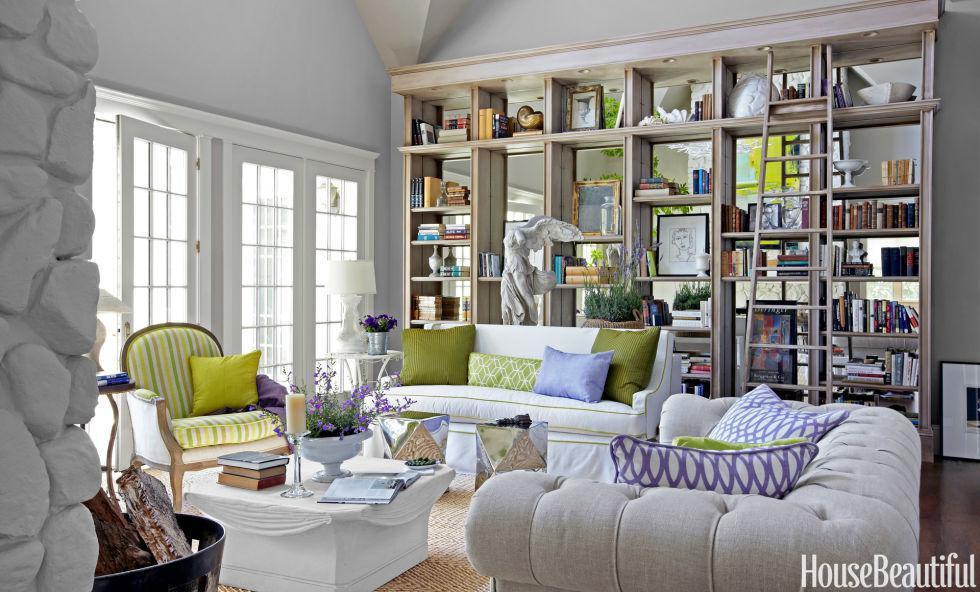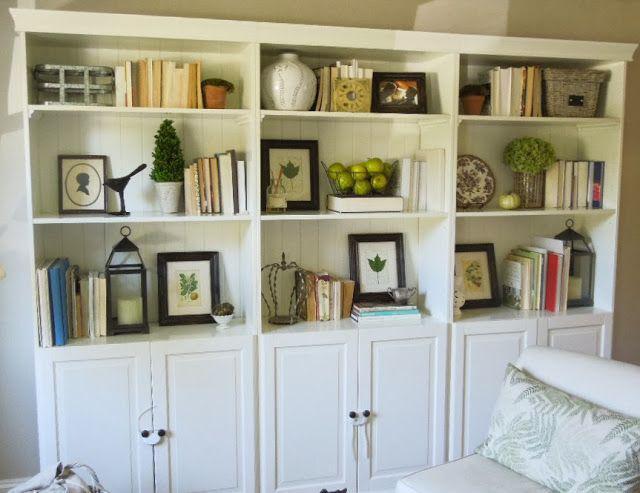The first image is the image on the left, the second image is the image on the right. Examine the images to the left and right. Is the description "In one image, living room couches and coffee table are arranged in front of a large shelving unit." accurate? Answer yes or no. Yes. The first image is the image on the left, the second image is the image on the right. Assess this claim about the two images: "In 1 of the images, the shelves have furniture in front of them.". Correct or not? Answer yes or no. Yes. 